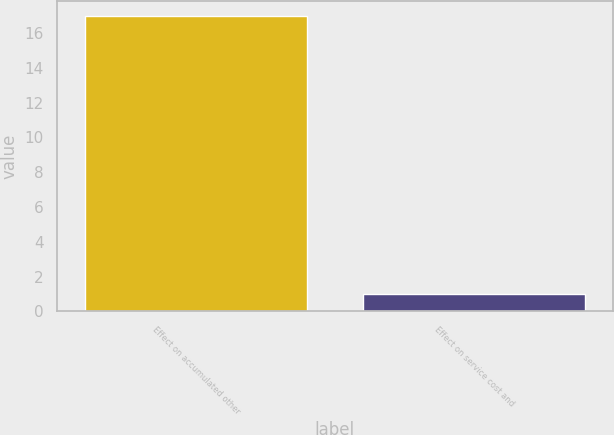Convert chart. <chart><loc_0><loc_0><loc_500><loc_500><bar_chart><fcel>Effect on accumulated other<fcel>Effect on service cost and<nl><fcel>17<fcel>1<nl></chart> 